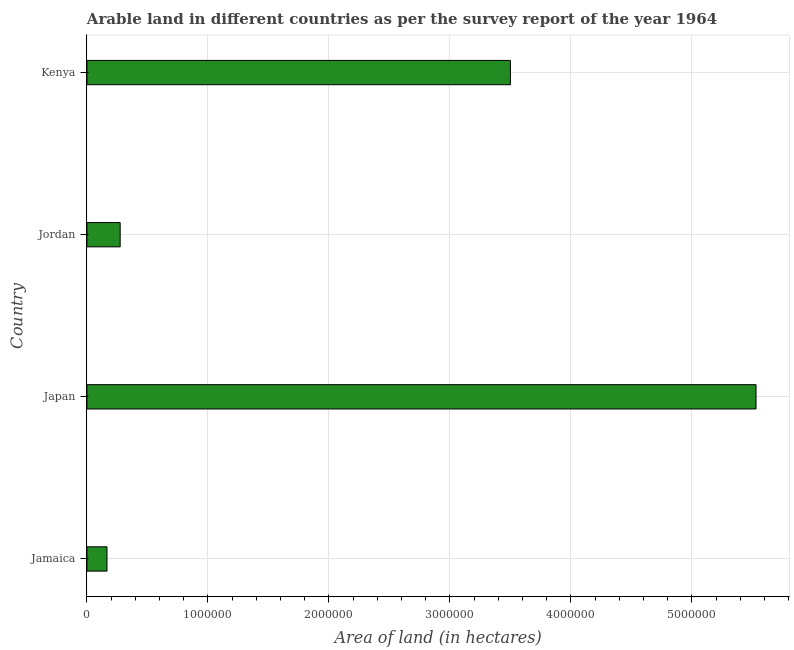What is the title of the graph?
Provide a succinct answer. Arable land in different countries as per the survey report of the year 1964. What is the label or title of the X-axis?
Make the answer very short. Area of land (in hectares). What is the label or title of the Y-axis?
Offer a very short reply. Country. What is the area of land in Jamaica?
Give a very brief answer. 1.66e+05. Across all countries, what is the maximum area of land?
Your answer should be very brief. 5.53e+06. Across all countries, what is the minimum area of land?
Ensure brevity in your answer.  1.66e+05. In which country was the area of land maximum?
Make the answer very short. Japan. In which country was the area of land minimum?
Your answer should be very brief. Jamaica. What is the sum of the area of land?
Ensure brevity in your answer.  9.47e+06. What is the difference between the area of land in Jamaica and Kenya?
Ensure brevity in your answer.  -3.33e+06. What is the average area of land per country?
Ensure brevity in your answer.  2.37e+06. What is the median area of land?
Provide a short and direct response. 1.89e+06. What is the ratio of the area of land in Japan to that in Jordan?
Keep it short and to the point. 20.11. Is the area of land in Japan less than that in Kenya?
Provide a succinct answer. No. Is the difference between the area of land in Jordan and Kenya greater than the difference between any two countries?
Ensure brevity in your answer.  No. What is the difference between the highest and the second highest area of land?
Give a very brief answer. 2.03e+06. What is the difference between the highest and the lowest area of land?
Give a very brief answer. 5.36e+06. How many bars are there?
Your response must be concise. 4. What is the Area of land (in hectares) in Jamaica?
Make the answer very short. 1.66e+05. What is the Area of land (in hectares) in Japan?
Provide a short and direct response. 5.53e+06. What is the Area of land (in hectares) of Jordan?
Ensure brevity in your answer.  2.75e+05. What is the Area of land (in hectares) in Kenya?
Provide a short and direct response. 3.50e+06. What is the difference between the Area of land (in hectares) in Jamaica and Japan?
Give a very brief answer. -5.36e+06. What is the difference between the Area of land (in hectares) in Jamaica and Jordan?
Offer a terse response. -1.09e+05. What is the difference between the Area of land (in hectares) in Jamaica and Kenya?
Provide a succinct answer. -3.33e+06. What is the difference between the Area of land (in hectares) in Japan and Jordan?
Keep it short and to the point. 5.26e+06. What is the difference between the Area of land (in hectares) in Japan and Kenya?
Offer a very short reply. 2.03e+06. What is the difference between the Area of land (in hectares) in Jordan and Kenya?
Your answer should be very brief. -3.22e+06. What is the ratio of the Area of land (in hectares) in Jamaica to that in Jordan?
Make the answer very short. 0.6. What is the ratio of the Area of land (in hectares) in Jamaica to that in Kenya?
Offer a very short reply. 0.05. What is the ratio of the Area of land (in hectares) in Japan to that in Jordan?
Offer a terse response. 20.11. What is the ratio of the Area of land (in hectares) in Japan to that in Kenya?
Make the answer very short. 1.58. What is the ratio of the Area of land (in hectares) in Jordan to that in Kenya?
Provide a succinct answer. 0.08. 